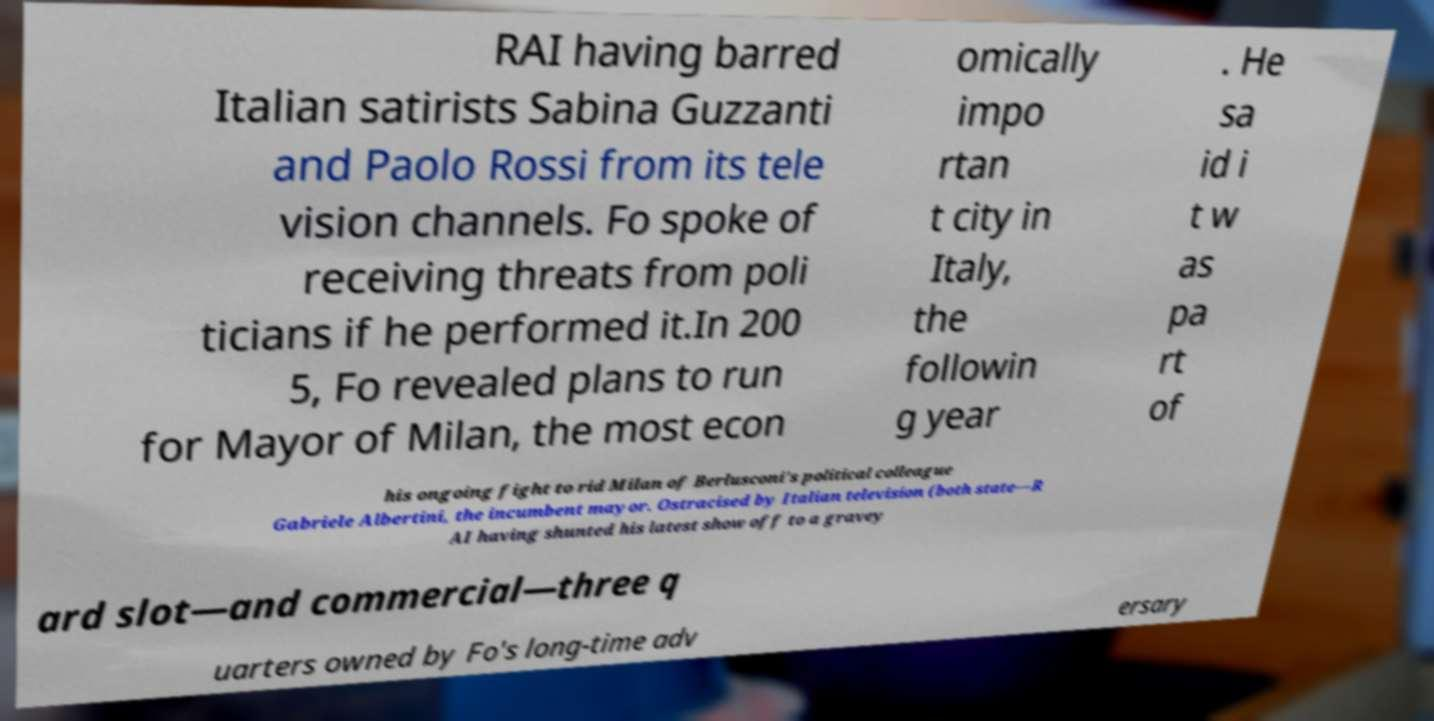What messages or text are displayed in this image? I need them in a readable, typed format. RAI having barred Italian satirists Sabina Guzzanti and Paolo Rossi from its tele vision channels. Fo spoke of receiving threats from poli ticians if he performed it.In 200 5, Fo revealed plans to run for Mayor of Milan, the most econ omically impo rtan t city in Italy, the followin g year . He sa id i t w as pa rt of his ongoing fight to rid Milan of Berlusconi's political colleague Gabriele Albertini, the incumbent mayor. Ostracised by Italian television (both state—R AI having shunted his latest show off to a gravey ard slot—and commercial—three q uarters owned by Fo's long-time adv ersary 